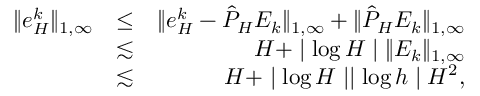Convert formula to latex. <formula><loc_0><loc_0><loc_500><loc_500>\begin{array} { r l r } { \| e _ { H } ^ { k } \| _ { 1 , \infty } } & { \leq } & { \| e _ { H } ^ { k } - \hat { P } _ { H } E _ { k } \| _ { 1 , \infty } + \| \hat { P } _ { H } E _ { k } \| _ { 1 , \infty } } \\ & { \lesssim } & { H + | \log H | \| E _ { k } \| _ { 1 , \infty } } \\ & { \lesssim } & { H + | \log H | | \log h | H ^ { 2 } , } \end{array}</formula> 